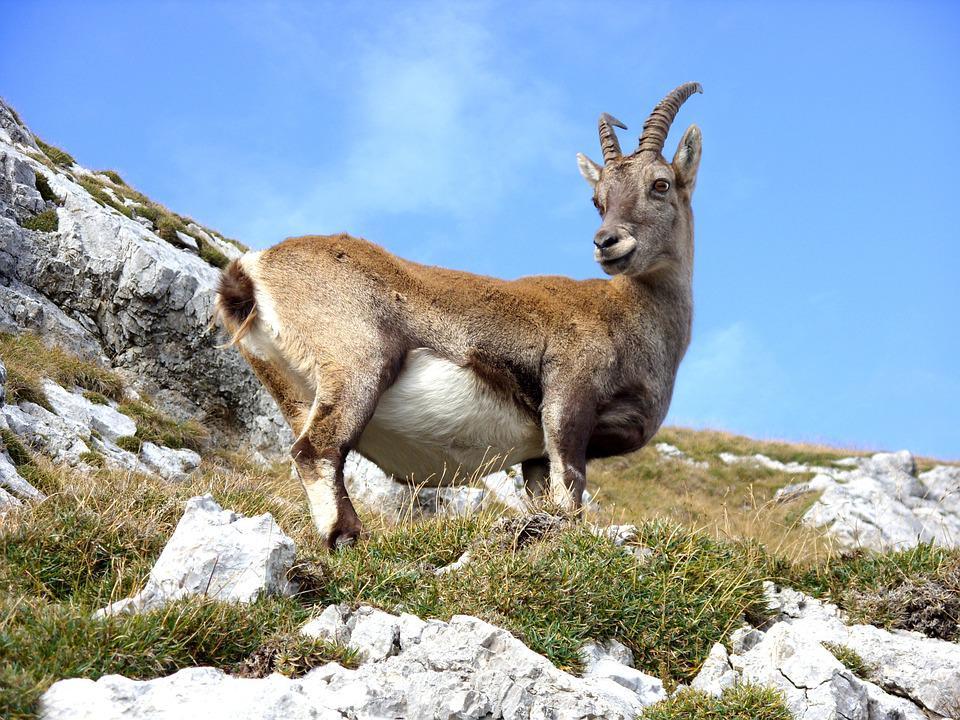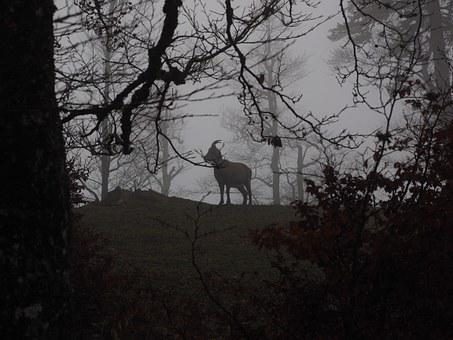The first image is the image on the left, the second image is the image on the right. Assess this claim about the two images: "An image shows a ram with its head in profile, in a stark scene with no trees or green vegetation.". Correct or not? Answer yes or no. No. The first image is the image on the left, the second image is the image on the right. Considering the images on both sides, is "There is a single animal standing in a rocky area in the image on the left." valid? Answer yes or no. Yes. 